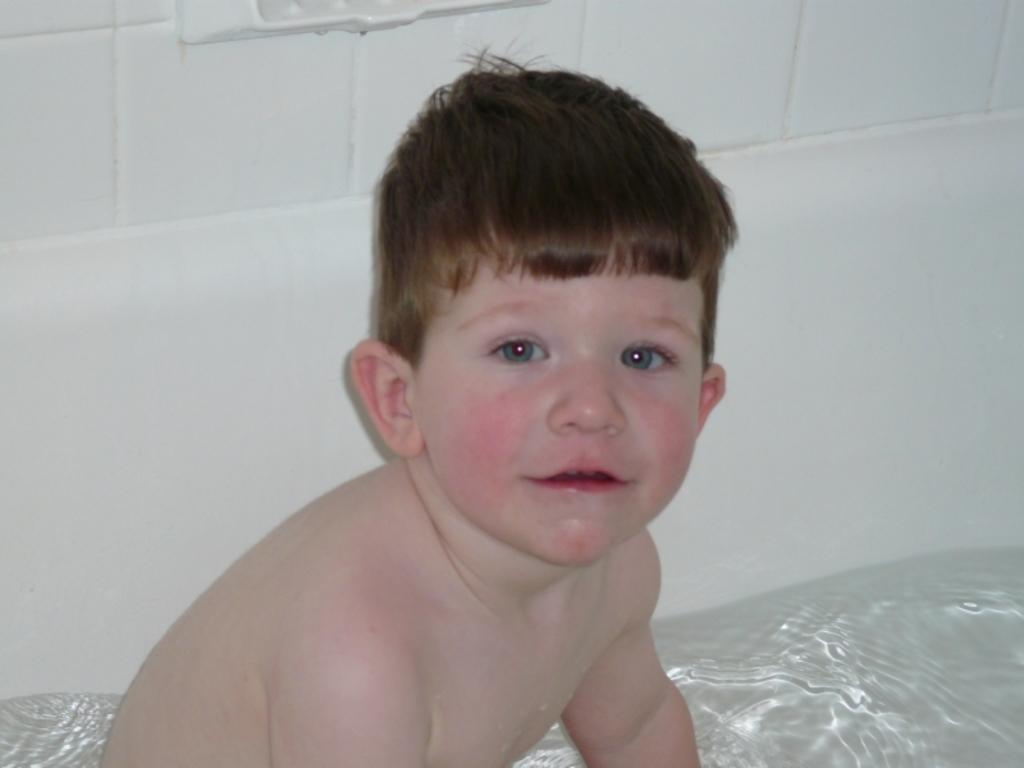What is the main subject in the front of the image? There is a kid in the front of the image. What can be seen in the background of the image? There is a wall in the background of the image. What type of net is being used by the kid in the image? There is no net present in the image; it only features a kid and a wall in the background. 